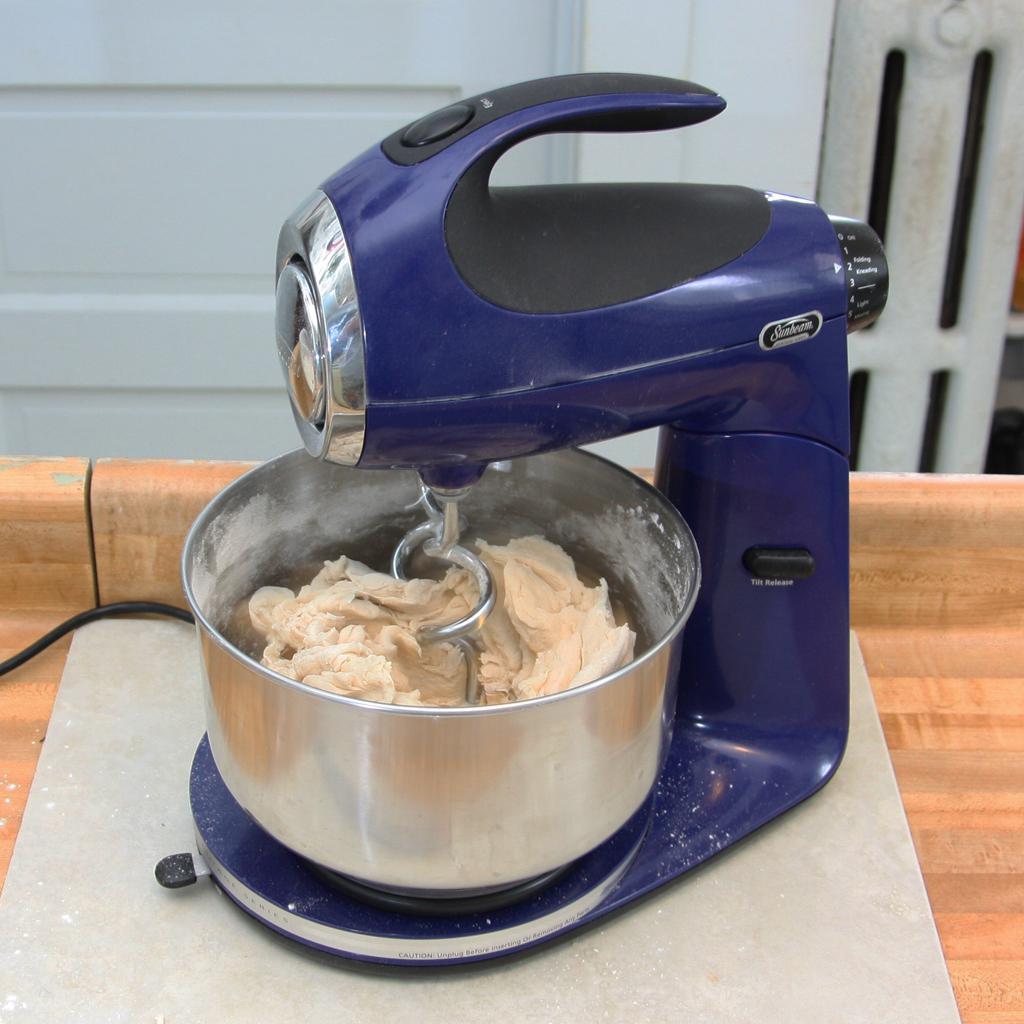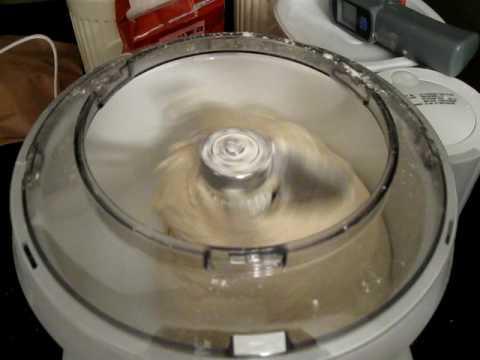The first image is the image on the left, the second image is the image on the right. Examine the images to the left and right. Is the description "The mixer in the left image has a black power cord." accurate? Answer yes or no. Yes. 